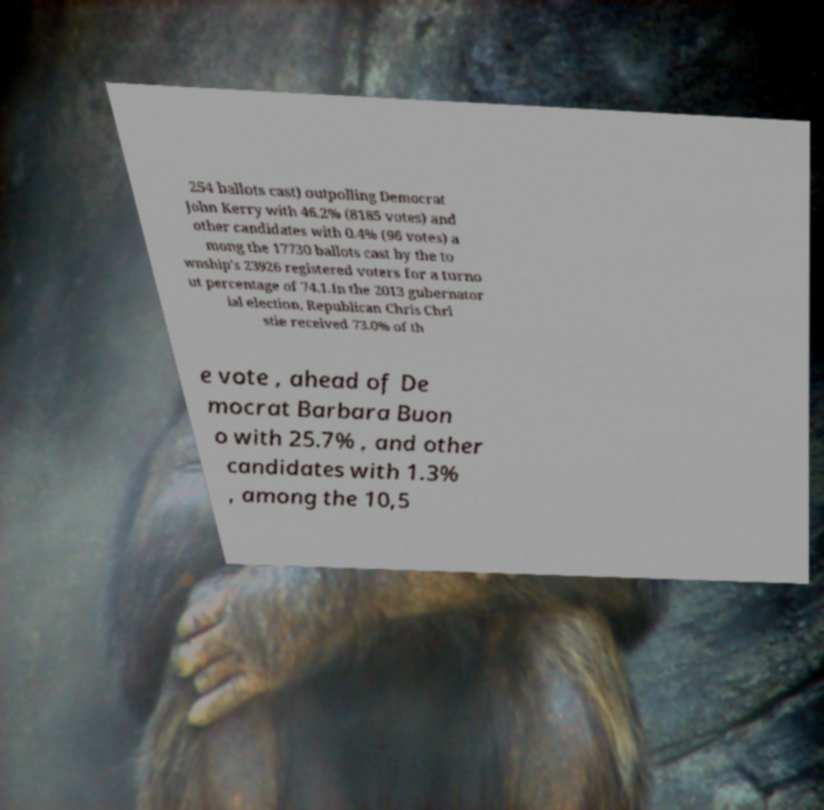Can you accurately transcribe the text from the provided image for me? 254 ballots cast) outpolling Democrat John Kerry with 46.2% (8185 votes) and other candidates with 0.4% (96 votes) a mong the 17730 ballots cast by the to wnship's 23926 registered voters for a turno ut percentage of 74.1.In the 2013 gubernator ial election, Republican Chris Chri stie received 73.0% of th e vote , ahead of De mocrat Barbara Buon o with 25.7% , and other candidates with 1.3% , among the 10,5 